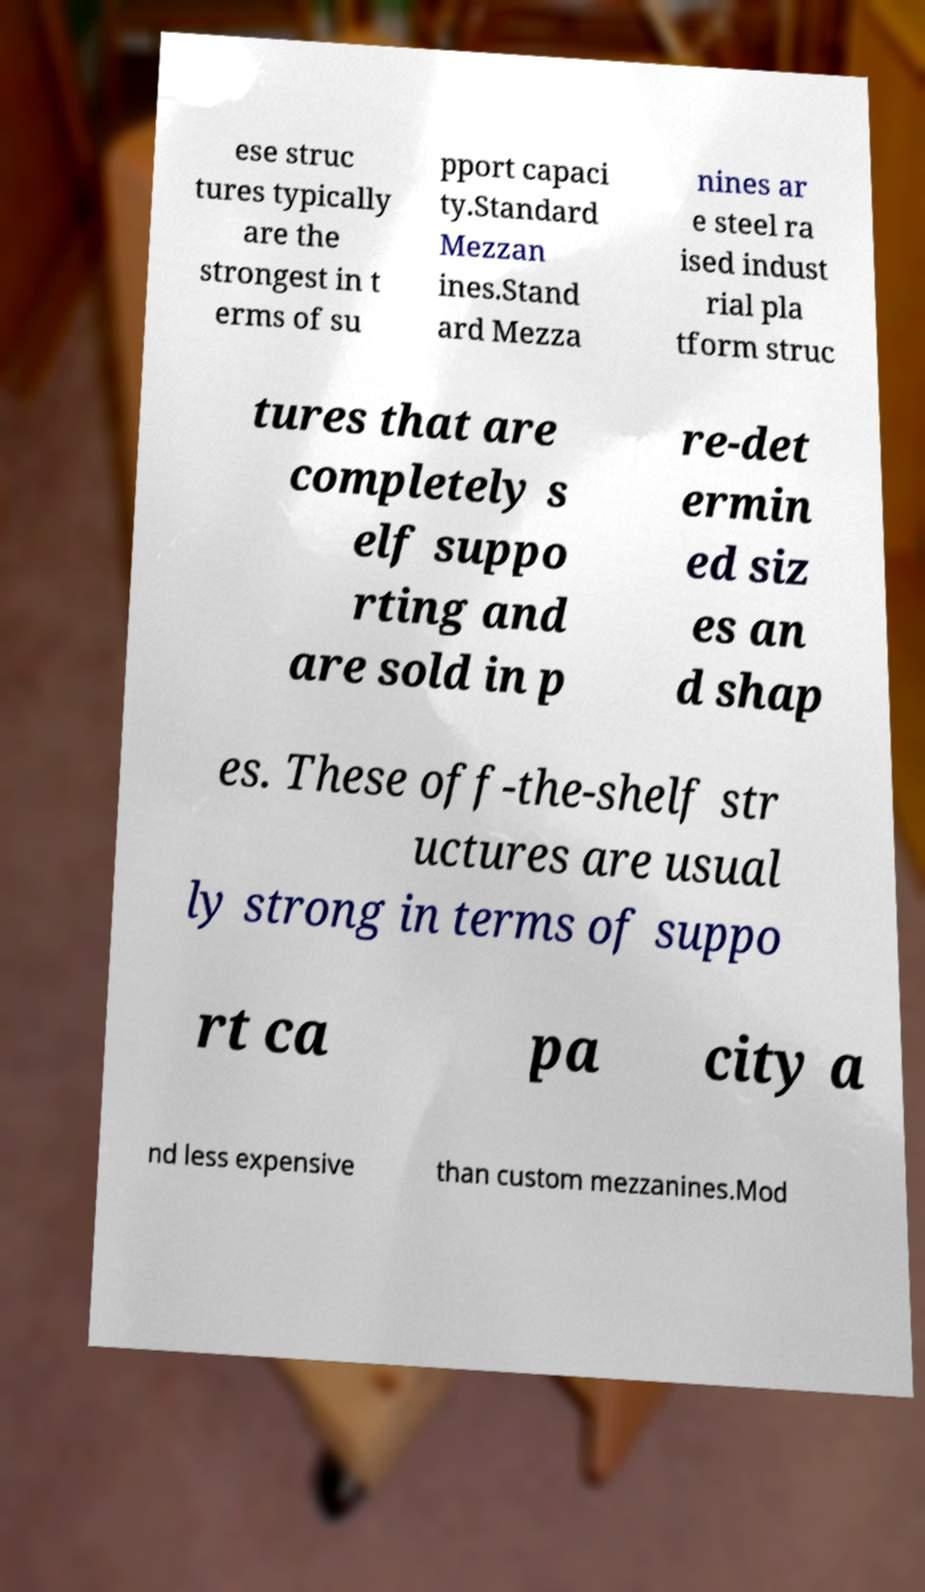Could you extract and type out the text from this image? ese struc tures typically are the strongest in t erms of su pport capaci ty.Standard Mezzan ines.Stand ard Mezza nines ar e steel ra ised indust rial pla tform struc tures that are completely s elf suppo rting and are sold in p re-det ermin ed siz es an d shap es. These off-the-shelf str uctures are usual ly strong in terms of suppo rt ca pa city a nd less expensive than custom mezzanines.Mod 